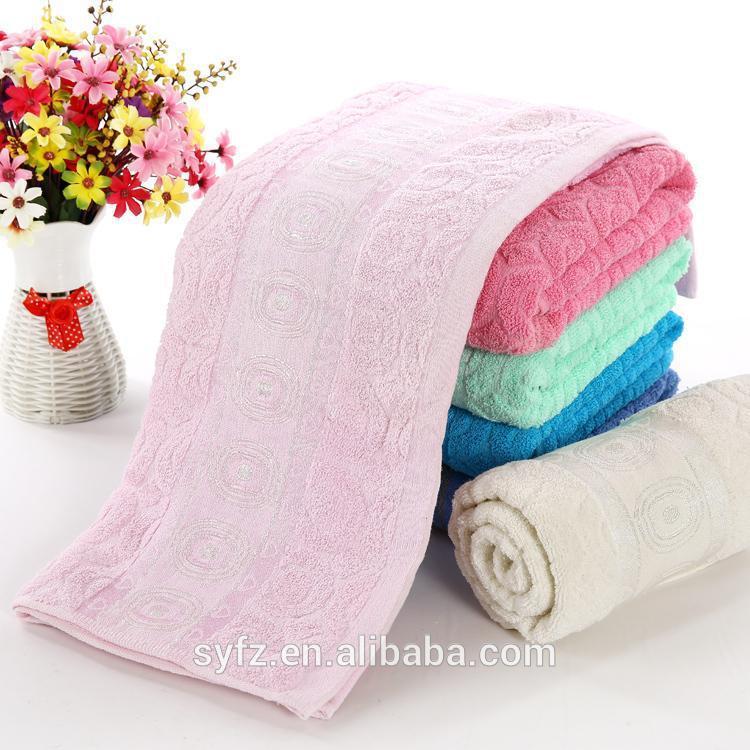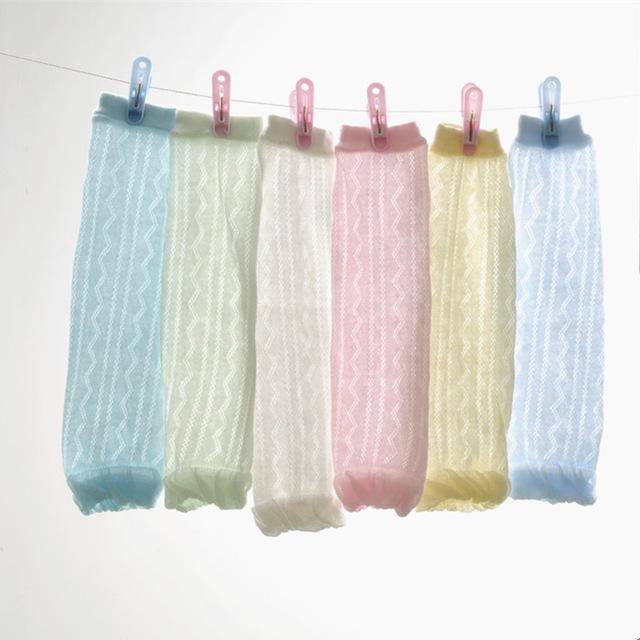The first image is the image on the left, the second image is the image on the right. Assess this claim about the two images: "All towels shown are solid colored, and at least one image shows a vertical stack of four different colored folded towels.". Correct or not? Answer yes or no. Yes. The first image is the image on the left, the second image is the image on the right. Examine the images to the left and right. Is the description "The left and right image contains the same number of fold or rolled towels." accurate? Answer yes or no. No. 